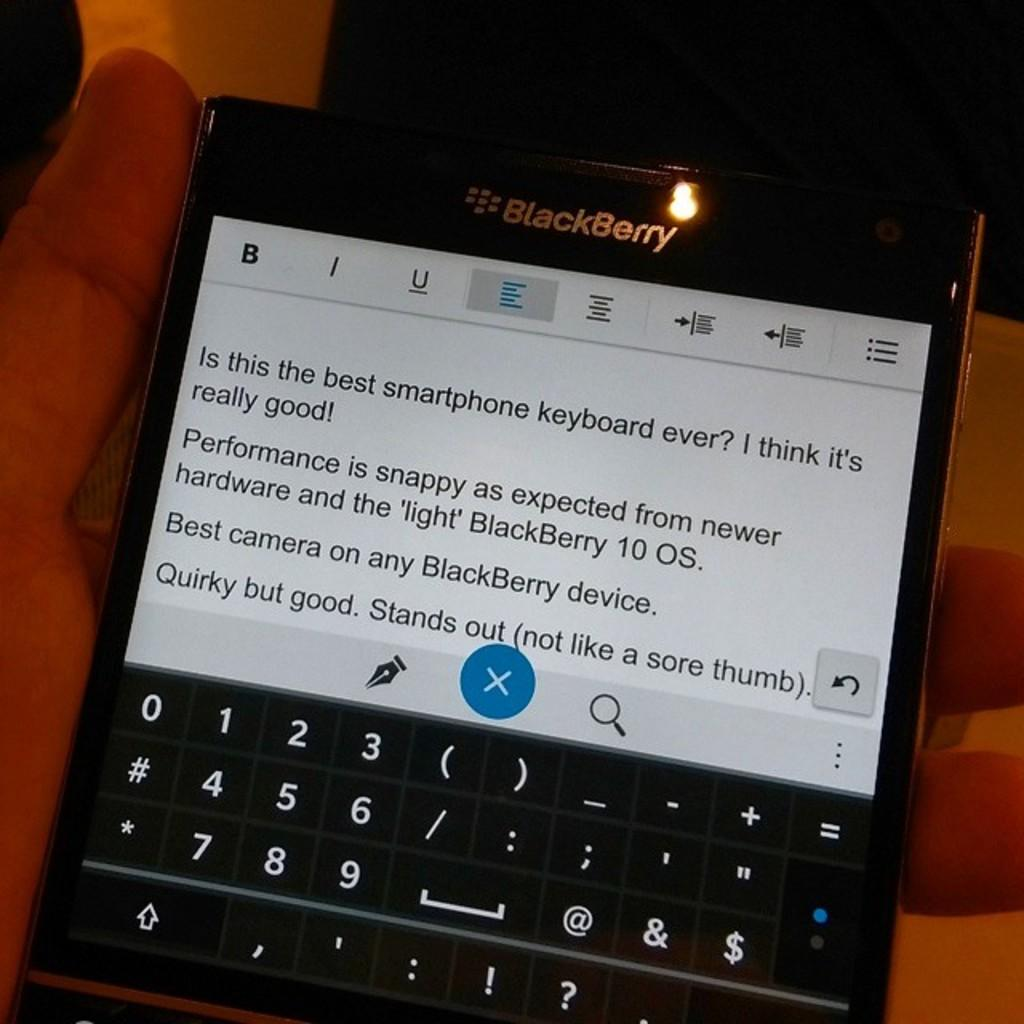<image>
Write a terse but informative summary of the picture. A hand is holding a Blackberry with a message showing on the screen. 